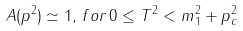<formula> <loc_0><loc_0><loc_500><loc_500>A ( p ^ { 2 } ) \simeq 1 , \, f o r \, 0 \leq T ^ { 2 } < m _ { 1 } ^ { 2 } + p _ { c } ^ { 2 }</formula> 